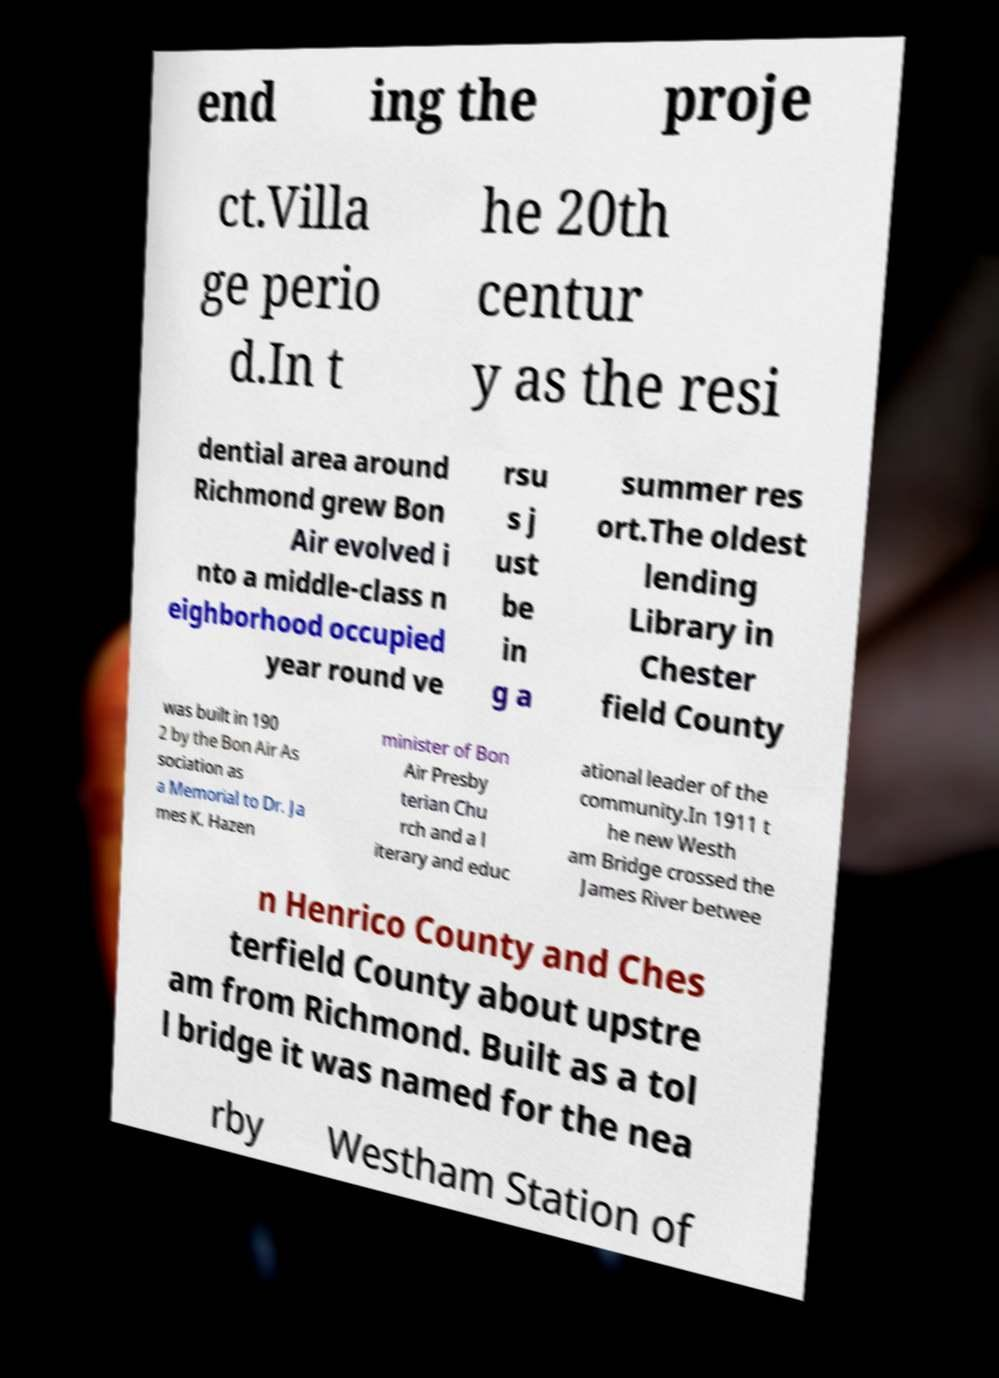Could you extract and type out the text from this image? end ing the proje ct.Villa ge perio d.In t he 20th centur y as the resi dential area around Richmond grew Bon Air evolved i nto a middle-class n eighborhood occupied year round ve rsu s j ust be in g a summer res ort.The oldest lending Library in Chester field County was built in 190 2 by the Bon Air As sociation as a Memorial to Dr. Ja mes K. Hazen minister of Bon Air Presby terian Chu rch and a l iterary and educ ational leader of the community.In 1911 t he new Westh am Bridge crossed the James River betwee n Henrico County and Ches terfield County about upstre am from Richmond. Built as a tol l bridge it was named for the nea rby Westham Station of 